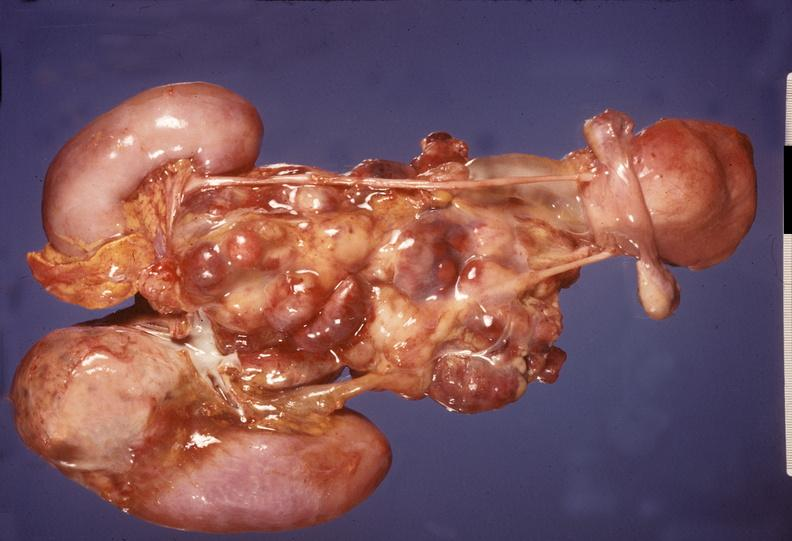s endocrine present?
Answer the question using a single word or phrase. Yes 